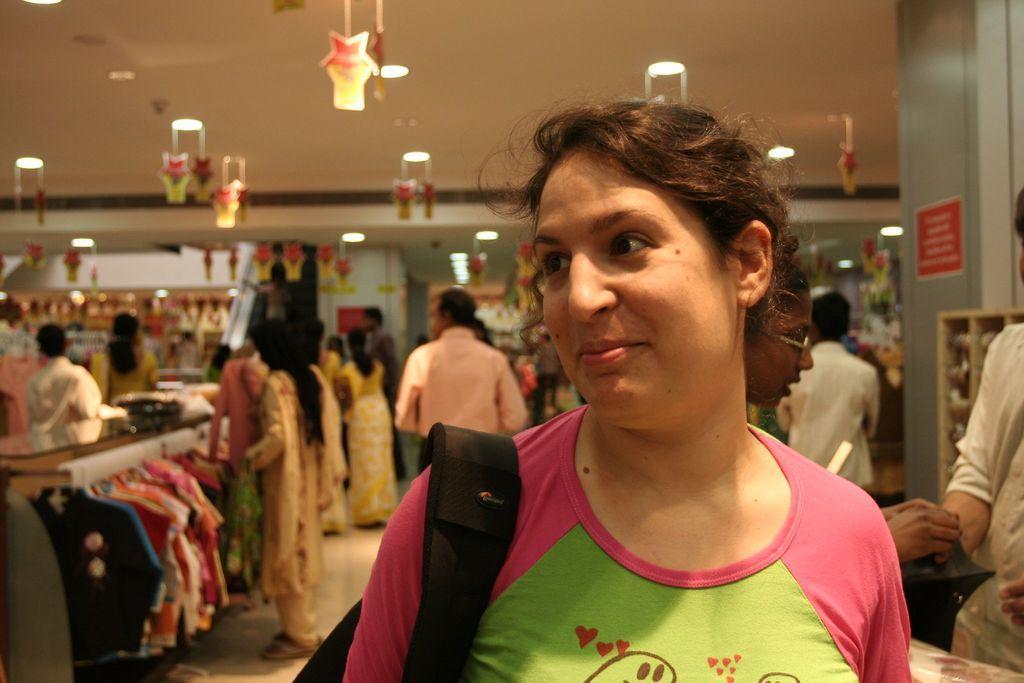Can you describe this image briefly? This picture shows an inner view of a store. we see clothes hanging to the hanger and we see few people standing and we see a woman standing and she wore a bag and we see smile on her face and we see lights to the ceiling. 